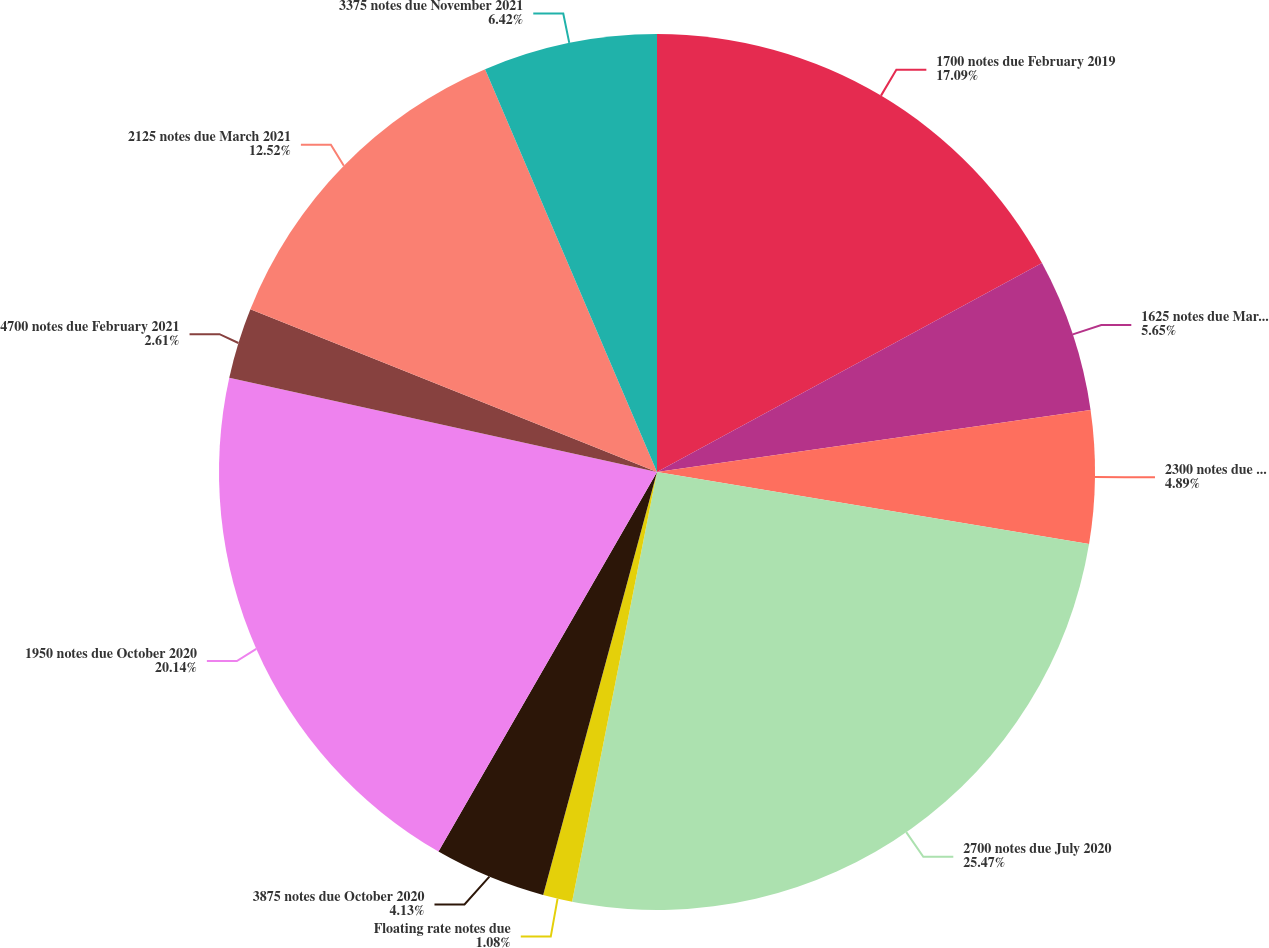<chart> <loc_0><loc_0><loc_500><loc_500><pie_chart><fcel>1700 notes due February 2019<fcel>1625 notes due March 2019<fcel>2300 notes due December 2019<fcel>2700 notes due July 2020<fcel>Floating rate notes due<fcel>3875 notes due October 2020<fcel>1950 notes due October 2020<fcel>4700 notes due February 2021<fcel>2125 notes due March 2021<fcel>3375 notes due November 2021<nl><fcel>17.09%<fcel>5.65%<fcel>4.89%<fcel>25.48%<fcel>1.08%<fcel>4.13%<fcel>20.14%<fcel>2.61%<fcel>12.52%<fcel>6.42%<nl></chart> 